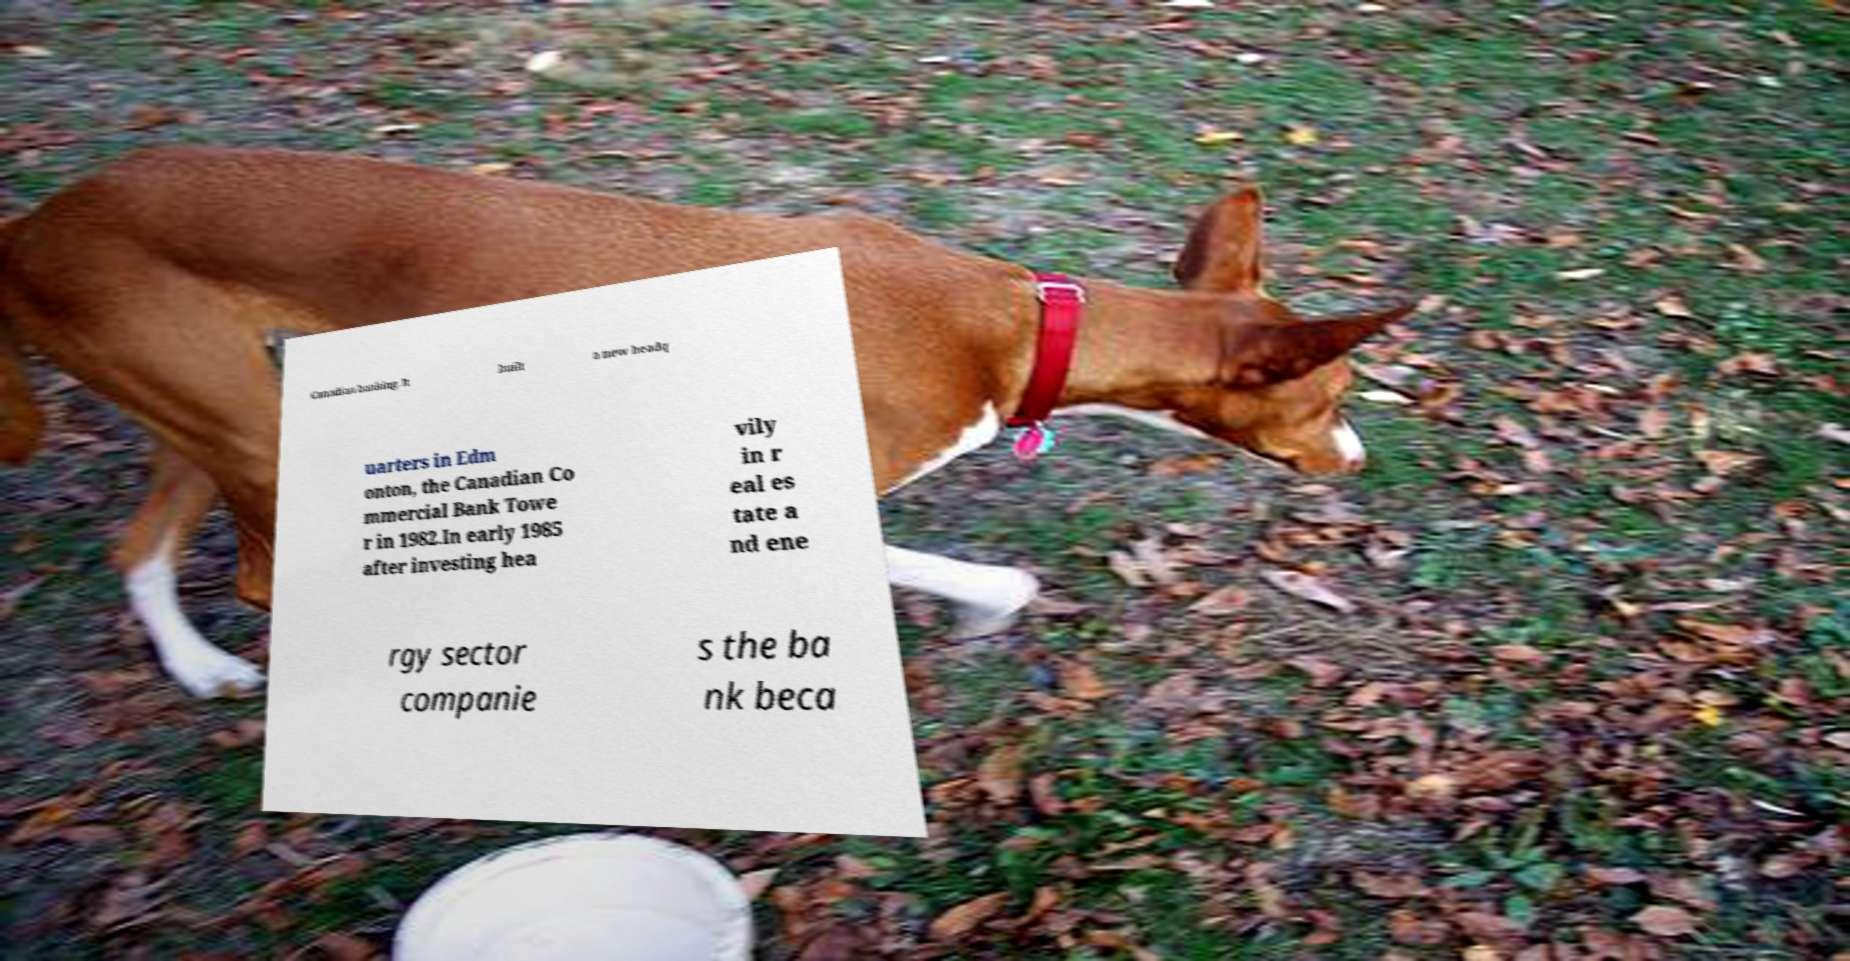What messages or text are displayed in this image? I need them in a readable, typed format. Canadian banking. It built a new headq uarters in Edm onton, the Canadian Co mmercial Bank Towe r in 1982.In early 1985 after investing hea vily in r eal es tate a nd ene rgy sector companie s the ba nk beca 